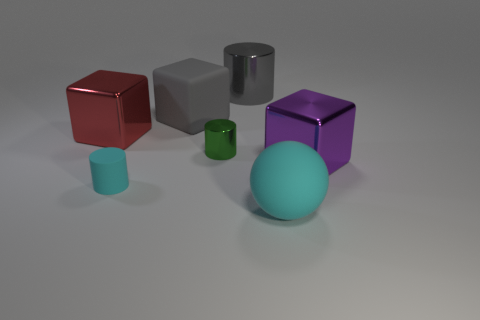The big thing that is both in front of the tiny green cylinder and behind the rubber cylinder is made of what material?
Keep it short and to the point. Metal. What number of gray cubes have the same size as the red shiny thing?
Offer a terse response. 1. There is a large gray object that is the same shape as the big purple metallic thing; what material is it?
Make the answer very short. Rubber. How many objects are large objects that are in front of the purple shiny object or small cylinders that are in front of the purple thing?
Make the answer very short. 2. There is a large cyan rubber object; does it have the same shape as the gray thing that is on the right side of the big rubber block?
Provide a short and direct response. No. There is a big rubber thing that is left of the large cyan thing in front of the block that is behind the red metal thing; what is its shape?
Give a very brief answer. Cube. What number of other objects are there of the same material as the green object?
Your response must be concise. 3. How many objects are either big metallic objects that are left of the big cyan rubber ball or purple rubber things?
Provide a short and direct response. 2. There is a big rubber object that is behind the large metal block behind the purple object; what shape is it?
Provide a short and direct response. Cube. There is a large matte object left of the tiny green cylinder; is it the same shape as the big purple shiny object?
Provide a succinct answer. Yes. 